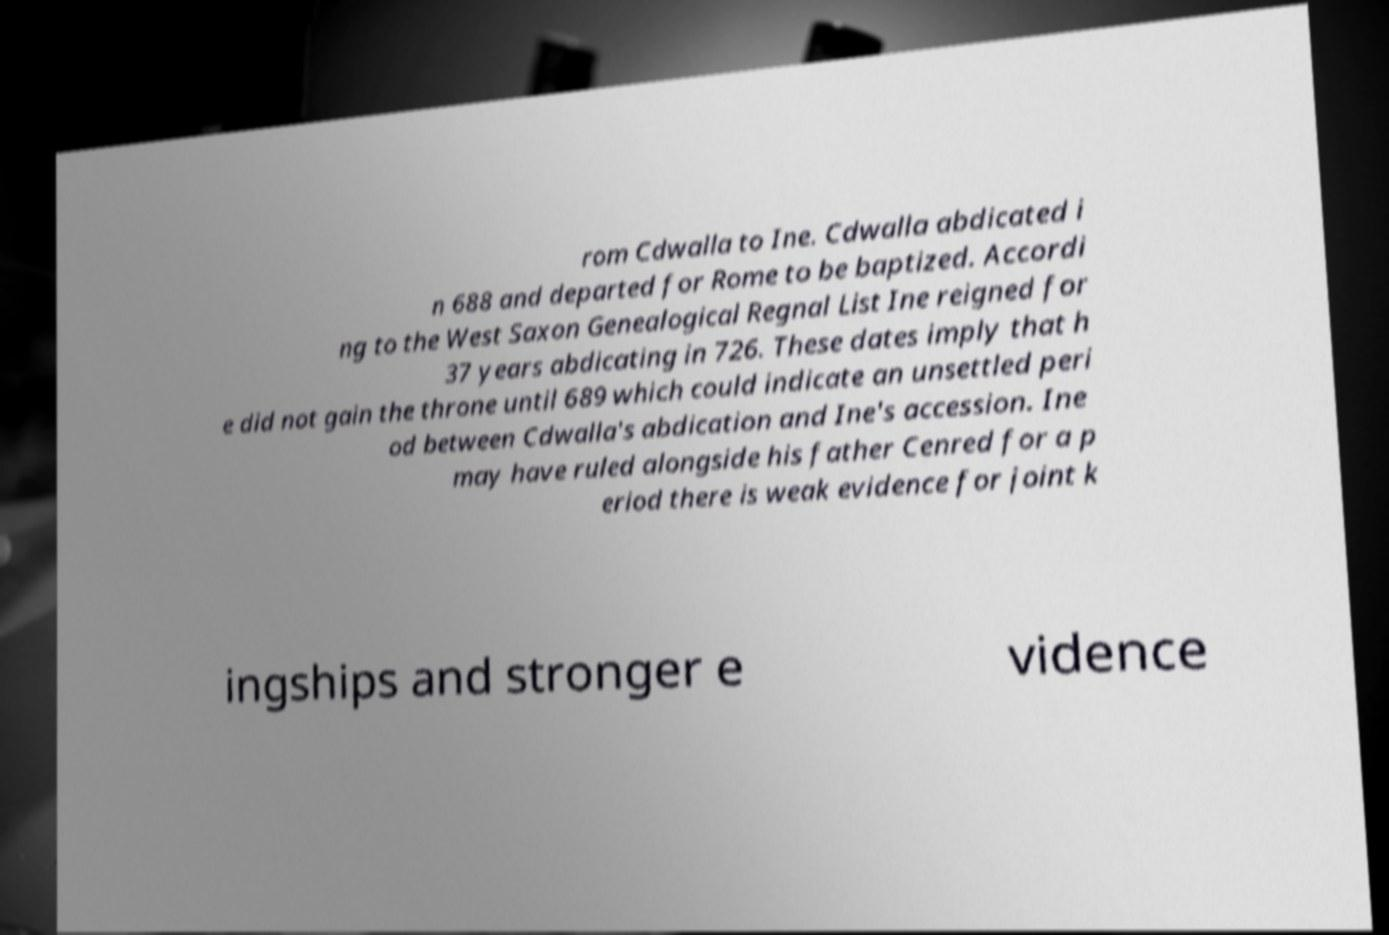What messages or text are displayed in this image? I need them in a readable, typed format. rom Cdwalla to Ine. Cdwalla abdicated i n 688 and departed for Rome to be baptized. Accordi ng to the West Saxon Genealogical Regnal List Ine reigned for 37 years abdicating in 726. These dates imply that h e did not gain the throne until 689 which could indicate an unsettled peri od between Cdwalla's abdication and Ine's accession. Ine may have ruled alongside his father Cenred for a p eriod there is weak evidence for joint k ingships and stronger e vidence 